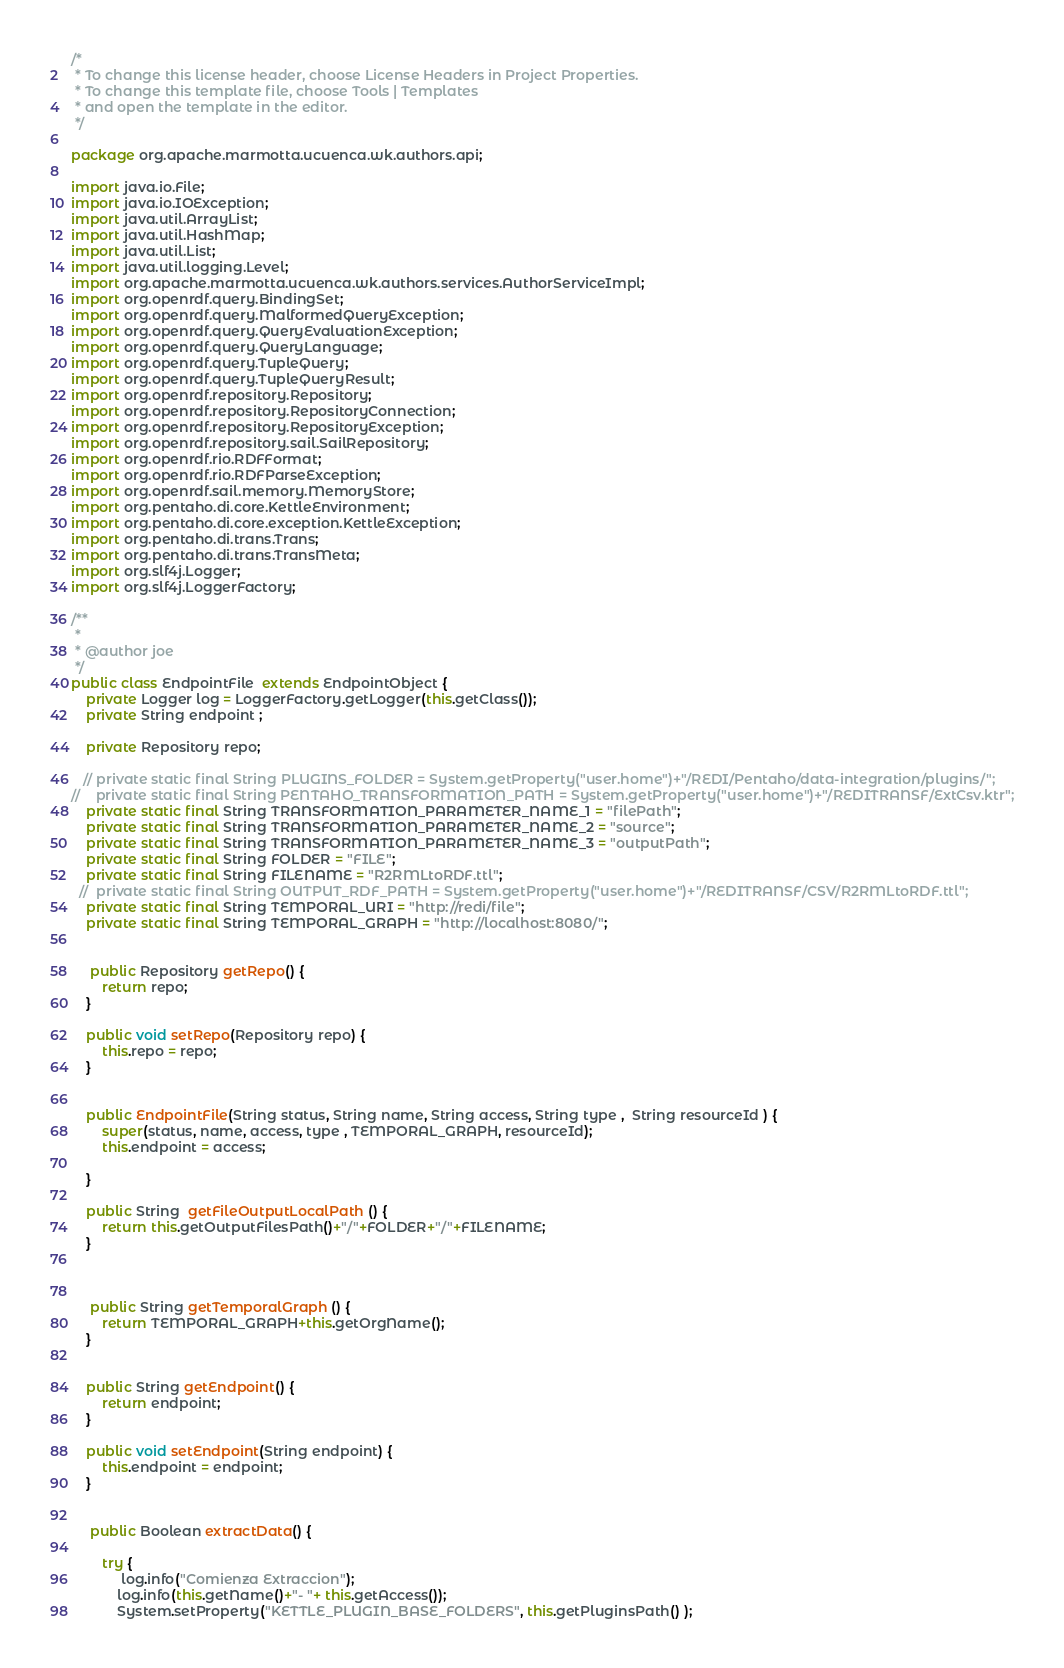Convert code to text. <code><loc_0><loc_0><loc_500><loc_500><_Java_>/*
 * To change this license header, choose License Headers in Project Properties.
 * To change this template file, choose Tools | Templates
 * and open the template in the editor.
 */

package org.apache.marmotta.ucuenca.wk.authors.api;

import java.io.File;
import java.io.IOException;
import java.util.ArrayList;
import java.util.HashMap;
import java.util.List;
import java.util.logging.Level;
import org.apache.marmotta.ucuenca.wk.authors.services.AuthorServiceImpl;
import org.openrdf.query.BindingSet;
import org.openrdf.query.MalformedQueryException;
import org.openrdf.query.QueryEvaluationException;
import org.openrdf.query.QueryLanguage;
import org.openrdf.query.TupleQuery;
import org.openrdf.query.TupleQueryResult;
import org.openrdf.repository.Repository;
import org.openrdf.repository.RepositoryConnection;
import org.openrdf.repository.RepositoryException;
import org.openrdf.repository.sail.SailRepository;
import org.openrdf.rio.RDFFormat;
import org.openrdf.rio.RDFParseException;
import org.openrdf.sail.memory.MemoryStore;
import org.pentaho.di.core.KettleEnvironment;
import org.pentaho.di.core.exception.KettleException;
import org.pentaho.di.trans.Trans;
import org.pentaho.di.trans.TransMeta;
import org.slf4j.Logger;
import org.slf4j.LoggerFactory;

/**
 *
 * @author joe
 */
public class EndpointFile  extends EndpointObject {
    private Logger log = LoggerFactory.getLogger(this.getClass());
    private String endpoint ;
 
    private Repository repo;
    
   // private static final String PLUGINS_FOLDER = System.getProperty("user.home")+"/REDI/Pentaho/data-integration/plugins/";
//    private static final String PENTAHO_TRANSFORMATION_PATH = System.getProperty("user.home")+"/REDITRANSF/ExtCsv.ktr";
    private static final String TRANSFORMATION_PARAMETER_NAME_1 = "filePath";
    private static final String TRANSFORMATION_PARAMETER_NAME_2 = "source";
    private static final String TRANSFORMATION_PARAMETER_NAME_3 = "outputPath";
    private static final String FOLDER = "FILE";
    private static final String FILENAME = "R2RMLtoRDF.ttl";
  //  private static final String OUTPUT_RDF_PATH = System.getProperty("user.home")+"/REDITRANSF/CSV/R2RMLtoRDF.ttl";
    private static final String TEMPORAL_URI = "http://redi/file";
    private static final String TEMPORAL_GRAPH = "http://localhost:8080/"; 
    
    
     public Repository getRepo() {
        return repo;
    }

    public void setRepo(Repository repo) {
        this.repo = repo;
    }

    
    public EndpointFile(String status, String name, String access, String type ,  String resourceId ) {
        super(status, name, access, type , TEMPORAL_GRAPH, resourceId);
        this.endpoint = access;
      
    }
    
    public String  getFileOutputLocalPath () {
        return this.getOutputFilesPath()+"/"+FOLDER+"/"+FILENAME;
    }
    

    
     public String getTemporalGraph () {
        return TEMPORAL_GRAPH+this.getOrgName();
    }
     
     
    public String getEndpoint() {
        return endpoint;
    }

    public void setEndpoint(String endpoint) {
        this.endpoint = endpoint;
    }

    
     public Boolean extractData() {
       
        try {
             log.info("Comienza Extraccion");
            log.info(this.getName()+"- "+ this.getAccess());
            System.setProperty("KETTLE_PLUGIN_BASE_FOLDERS", this.getPluginsPath() );</code> 